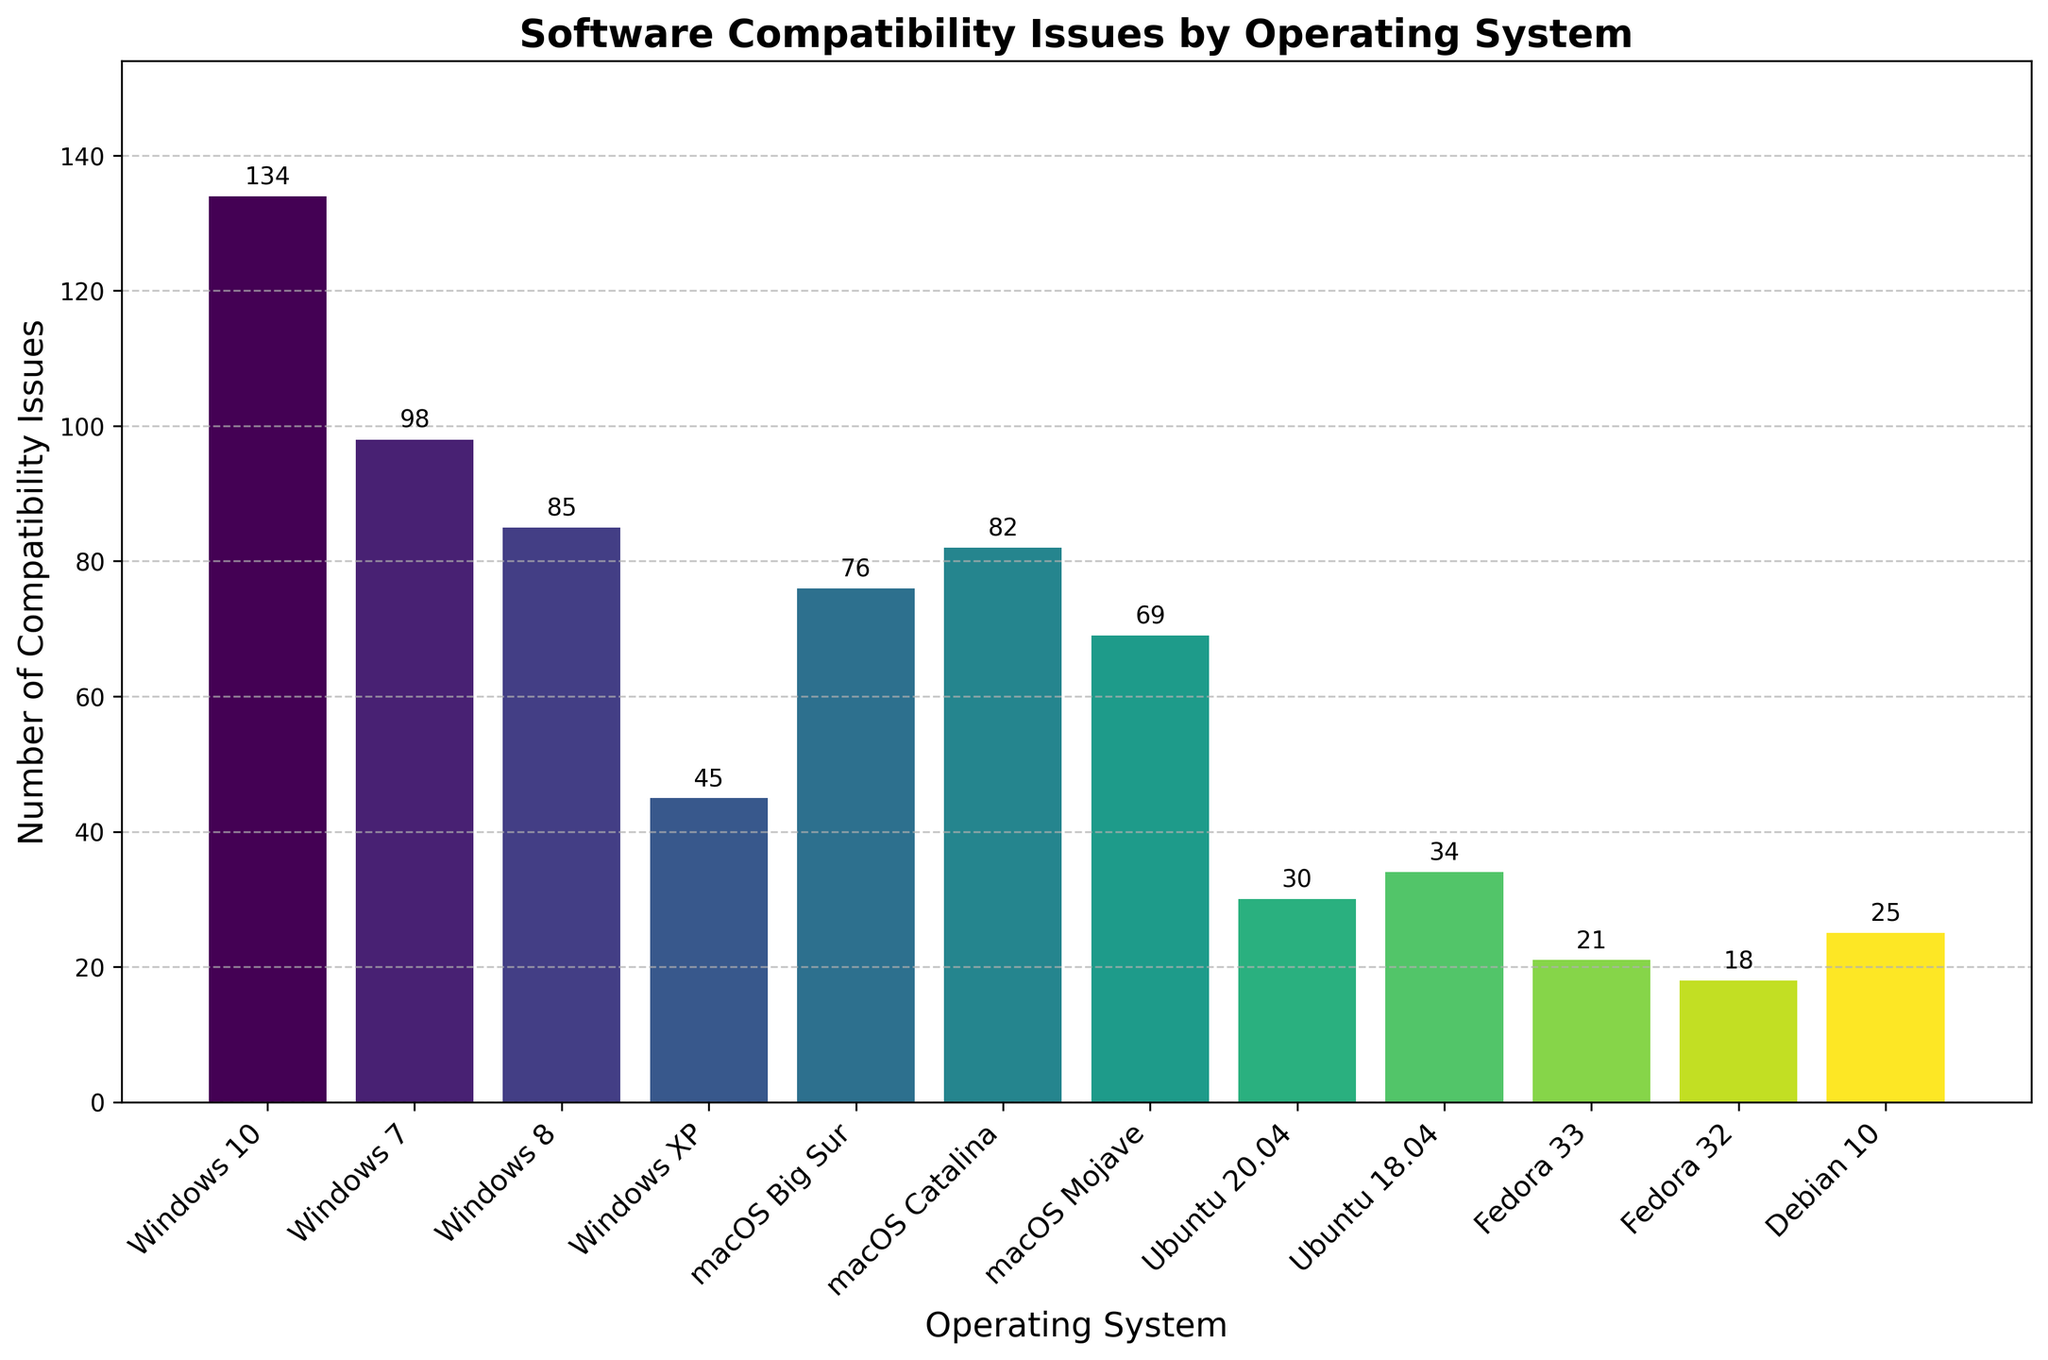what are the operating systems with the most and the fewest compatibility issues? By looking at the bar lengths in the plot, we see that Windows 10 has the highest bar representing 134 compatibility issues, while Fedora 32 has the shortest bar representing 18 compatibility issues.
Answer: Windows 10 and Fedora 32 How many compatibility issues do the macOS versions have in total? Summing the heights of the bars for macOS Big Sur (76), macOS Catalina (82), and macOS Mojave (69), we get 76 + 82 + 69 = 227.
Answer: 227 What is the average number of compatibility issues across all operating systems? Calculate the total sum of compatibility issues and divide by the number of operating systems. The sum is 134 + 98 + 85 + 45 + 76 + 82 + 69 + 30 + 34 + 21 + 18 + 25 = 717. There are 12 operating systems: 717 / 12 ≈ 59.75.
Answer: 59.75 Which operating system has fewer compatibility issues, Ubuntu 20.04 or Ubuntu 18.04? Looking at the bars representing these systems, Ubuntu 20.04 has 30 issues, and Ubuntu 18.04 has 34 issues. 30 is less than 34.
Answer: Ubuntu 20.04 How many more compatibility issues does Windows 7 have compared to Debian 10? Subtract the Compatibility Issues of Debian 10 (25) from Windows 7 (98): 98 - 25 = 73.
Answer: 73 What is the difference in the number of compatibility issues between Windows 8 and macOS Catalina? Subtract the Compatibility Issues of Windows 8 (85) from macOS Catalina (82): 85 - 82 = 3.
Answer: 3 Which operating system has a bar height approximately three times that of Fedora 32? Fedora 32 has 18 issues. Approximately three times this value is 18 * 3 = 54. Looking at the bars, Windows XP with 45 issues is the closest match.
Answer: Windows XP What is the range (difference between the highest and lowest values) of compatibility issues across all operating systems? Subtract the smallest number of issues (Fedora 32 with 18) from the largest number (Windows 10 with 134): 134 - 18 = 116.
Answer: 116 Compare the number of compatibility issues for all Windows operating systems combined and all Linux operating systems combined. Which category has more? Summing the issues for Windows (134 + 98 + 85 + 45 = 362) and for Linux (Ubuntu 20.04: 30, Ubuntu 18.04: 34, Fedora 33: 21, Fedora 32: 18, Debian 10: 25; 30 + 34 + 21 + 18 + 25 = 128). Comparing 362 and 128, Windows has more.
Answer: Windows 